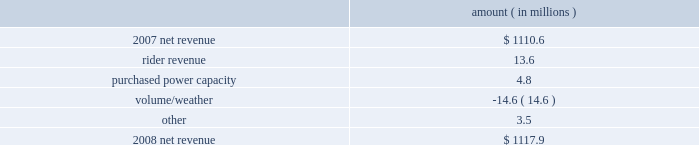Entergy arkansas , inc .
Management's financial discussion and analysis results of operations net income 2008 compared to 2007 net income decreased $ 92.0 million primarily due to higher other operation and maintenance expenses , higher depreciation and amortization expenses , and a higher effective income tax rate , partially offset by higher net revenue .
The higher other operation and maintenance expenses resulted primarily from the write-off of approximately $ 70.8 million of costs as a result of the december 2008 arkansas court of appeals decision in entergy arkansas' base rate case .
The base rate case is discussed in more detail in note 2 to the financial statements .
2007 compared to 2006 net income decreased $ 34.0 million primarily due to higher other operation and maintenance expenses , higher depreciation and amortization expenses , and a higher effective income tax rate .
The decrease was partially offset by higher net revenue .
Net revenue 2008 compared to 2007 net revenue consists of operating revenues net of : 1 ) fuel , fuel-related expenses , and gas purchased for resale , 2 ) purchased power expenses , and 3 ) other regulatory credits .
Following is an analysis of the change in net revenue comparing 2008 to 2007 .
Amount ( in millions ) .
The rider revenue variance is primarily due to an energy efficiency rider which became effective in november 2007 .
The establishment of the rider results in an increase in rider revenue and a corresponding increase in other operation and maintenance expense with no effect on net income .
Also contributing to the variance was an increase in franchise tax rider revenue as a result of higher retail revenues .
The corresponding increase is in taxes other than income taxes , resulting in no effect on net income .
The purchased power capacity variance is primarily due to lower reserve equalization expenses .
The volume/weather variance is primarily due to the effect of less favorable weather on residential and commercial sales during the billed and unbilled sales periods compared to 2007 and a 2.9% ( 2.9 % ) volume decrease in industrial sales , primarily in the wood industry and the small customer class .
Billed electricity usage decreased 333 gwh in all sectors .
See "critical accounting estimates" below and note 1 to the financial statements for further discussion of the accounting for unbilled revenues. .
What is the growth rate in net revenue in 2008 for entergy arkansas? 
Computations: ((1117.9 - 1110.6) / 1110.6)
Answer: 0.00657. Entergy arkansas , inc .
Management's financial discussion and analysis results of operations net income 2008 compared to 2007 net income decreased $ 92.0 million primarily due to higher other operation and maintenance expenses , higher depreciation and amortization expenses , and a higher effective income tax rate , partially offset by higher net revenue .
The higher other operation and maintenance expenses resulted primarily from the write-off of approximately $ 70.8 million of costs as a result of the december 2008 arkansas court of appeals decision in entergy arkansas' base rate case .
The base rate case is discussed in more detail in note 2 to the financial statements .
2007 compared to 2006 net income decreased $ 34.0 million primarily due to higher other operation and maintenance expenses , higher depreciation and amortization expenses , and a higher effective income tax rate .
The decrease was partially offset by higher net revenue .
Net revenue 2008 compared to 2007 net revenue consists of operating revenues net of : 1 ) fuel , fuel-related expenses , and gas purchased for resale , 2 ) purchased power expenses , and 3 ) other regulatory credits .
Following is an analysis of the change in net revenue comparing 2008 to 2007 .
Amount ( in millions ) .
The rider revenue variance is primarily due to an energy efficiency rider which became effective in november 2007 .
The establishment of the rider results in an increase in rider revenue and a corresponding increase in other operation and maintenance expense with no effect on net income .
Also contributing to the variance was an increase in franchise tax rider revenue as a result of higher retail revenues .
The corresponding increase is in taxes other than income taxes , resulting in no effect on net income .
The purchased power capacity variance is primarily due to lower reserve equalization expenses .
The volume/weather variance is primarily due to the effect of less favorable weather on residential and commercial sales during the billed and unbilled sales periods compared to 2007 and a 2.9% ( 2.9 % ) volume decrease in industrial sales , primarily in the wood industry and the small customer class .
Billed electricity usage decreased 333 gwh in all sectors .
See "critical accounting estimates" below and note 1 to the financial statements for further discussion of the accounting for unbilled revenues. .
What is the percent change in net revenue between 2007 and 2008? 
Computations: ((1110.6 - 1117.9) / 1117.9)
Answer: -0.00653. 